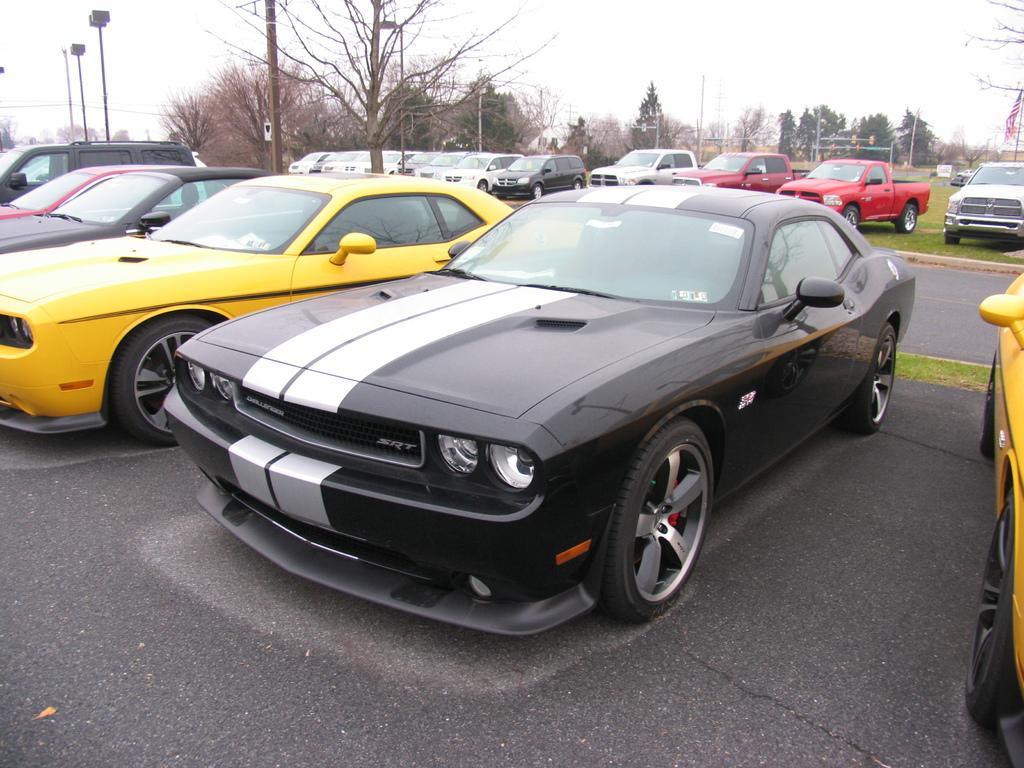Could you give a brief overview of what you see in this image? In the picture many cars are parked beside the road and in between those cars there are few trees. 